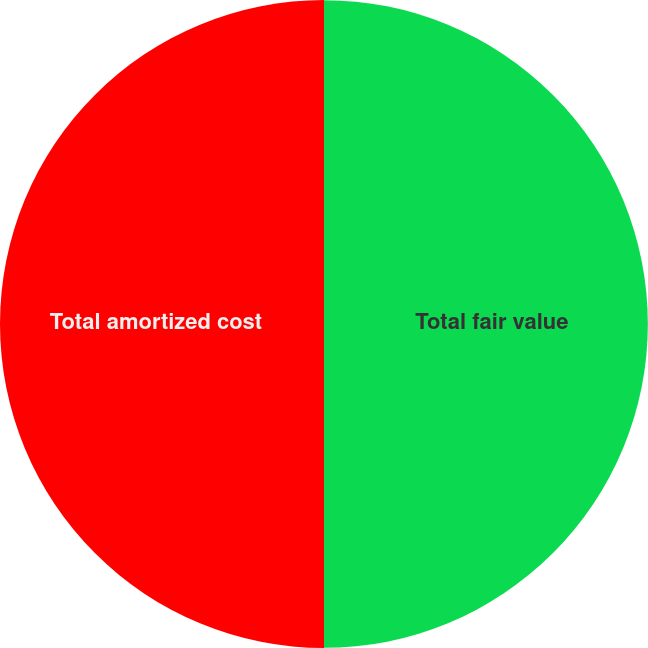<chart> <loc_0><loc_0><loc_500><loc_500><pie_chart><fcel>Total fair value<fcel>Total amortized cost<nl><fcel>49.99%<fcel>50.01%<nl></chart> 